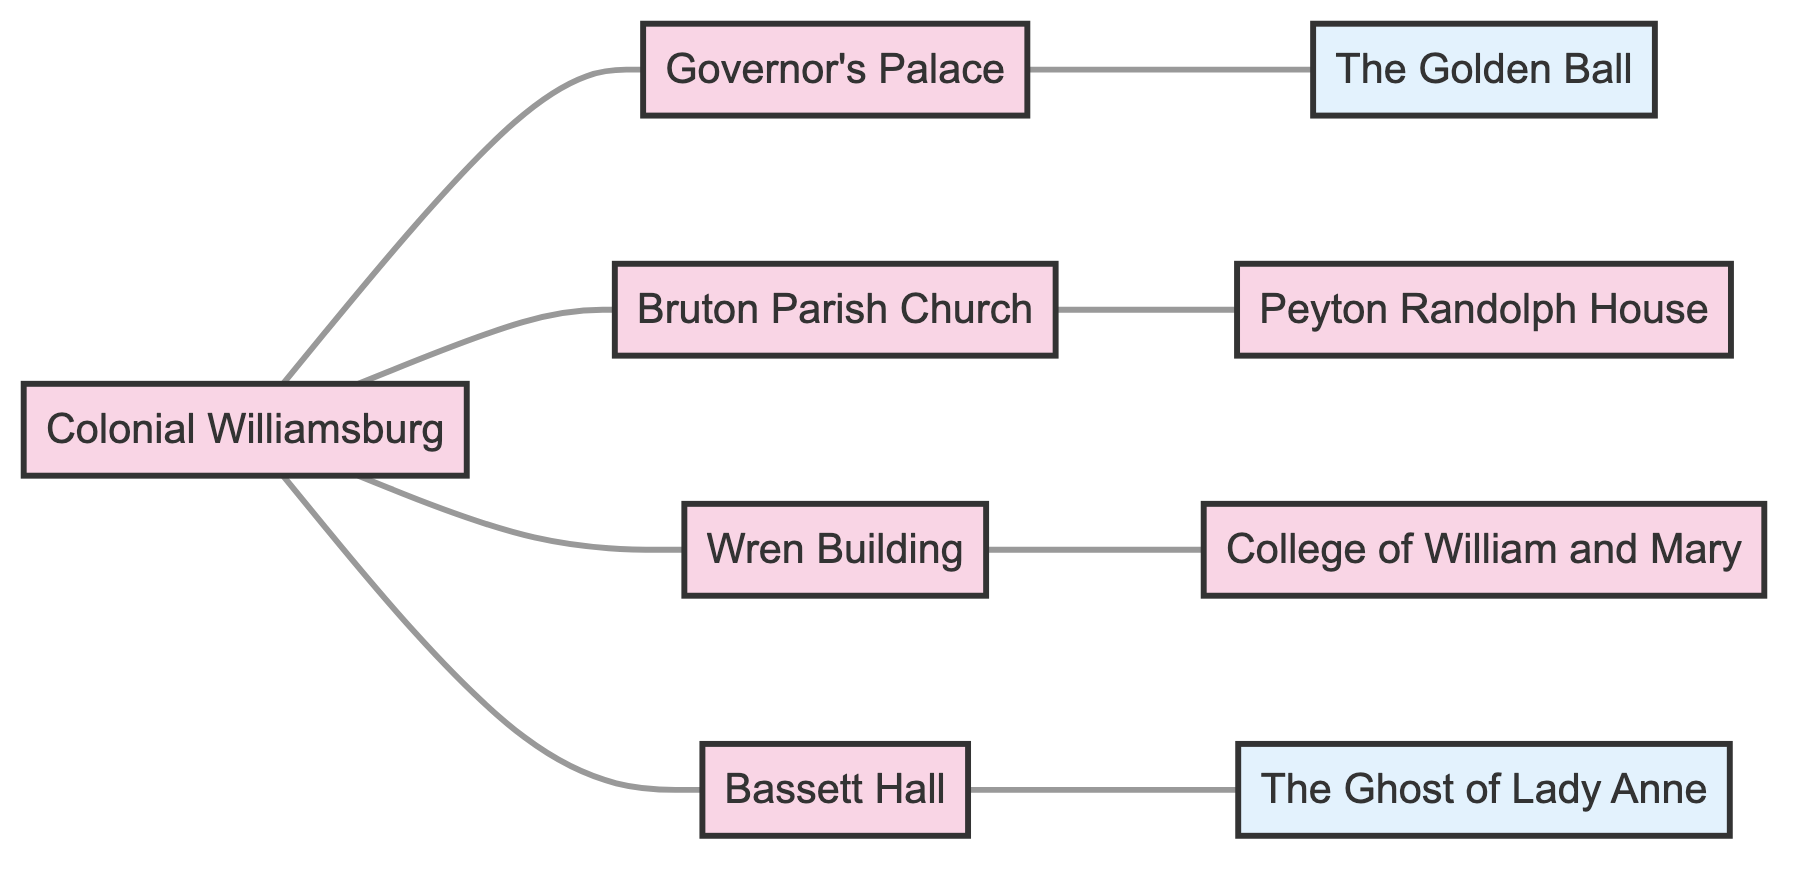What is the total number of nodes in the diagram? The diagram contains eight distinct locations or legends represented by nodes. Each node corresponds to a landmark or local legend in the graph.
Answer: 8 Which two nodes are directly connected to Bruton Parish Church? Bruton Parish Church is connected directly to two other nodes: the Colonial Williamsburg node and the Peyton Randolph House node, indicating a direct relationship with each of them.
Answer: Colonial Williamsburg, Peyton Randolph House Is the Wren Building connected to the College of William and Mary? Yes, the Wren Building is directly connected to the College of William and Mary as indicated by a solid line representing their relationship in the diagram.
Answer: Yes How many legend nodes are present in the diagram? The diagram features two nodes that are designated as legends, which are The Golden Ball and The Ghost of Lady Anne. These can be identified by their defined visuals in the graph.
Answer: 2 Which landmark connects to The Golden Ball? The Governor's Palace is the only landmark that connects directly to The Golden Ball, as shown by the link indicated in the graph.
Answer: Governor's Palace What is the connecting relationship between Bassett Hall and The Ghost of Lady Anne? Bassett Hall has a direct connection to The Ghost of Lady Anne, indicating a significant relationship between the landmark and the local legend.
Answer: Directly connected Which landmark has the most connections in the diagram? Colonial Williamsburg has four direct connections to other landmarks: Governor's Palace, Bruton Parish Church, Wren Building, and Bassett Hall, making it the landmark with the most connections.
Answer: Colonial Williamsburg How many edges are there in total in the graph? The total number of edges corresponds to the direct links between nodes, which is eight in this case. Each connection between a pair of nodes is counted as one edge.
Answer: 8 